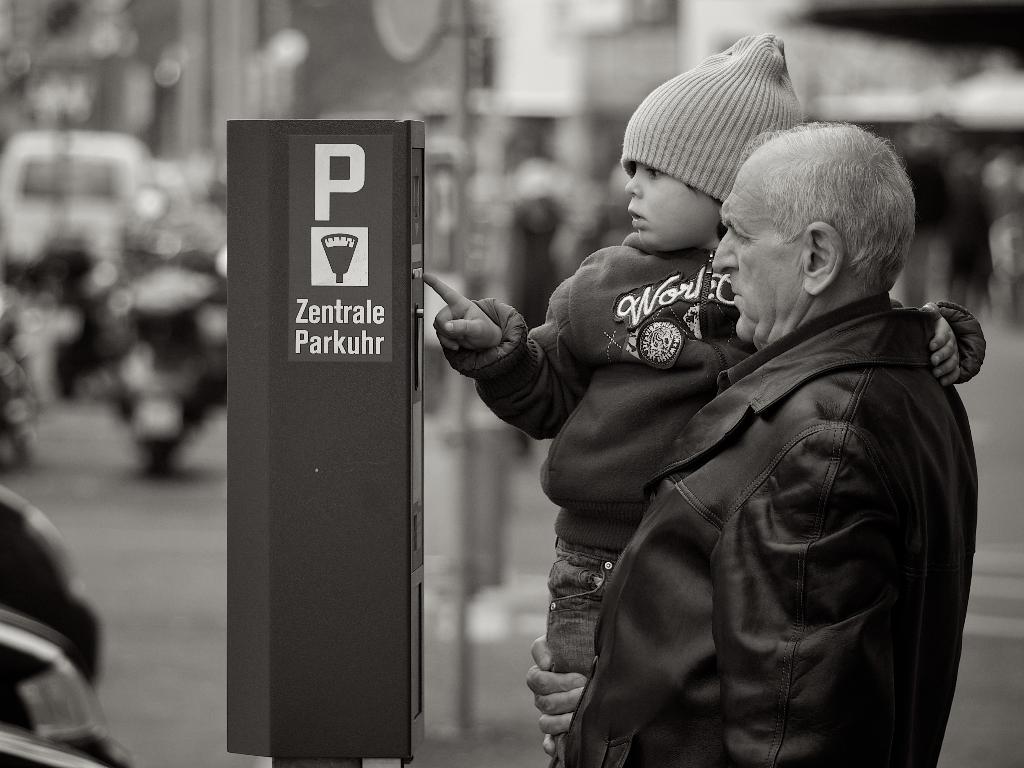What is this a machine for?
Keep it short and to the point. Parking. What big single letter is on this machine?
Your answer should be very brief. P. 